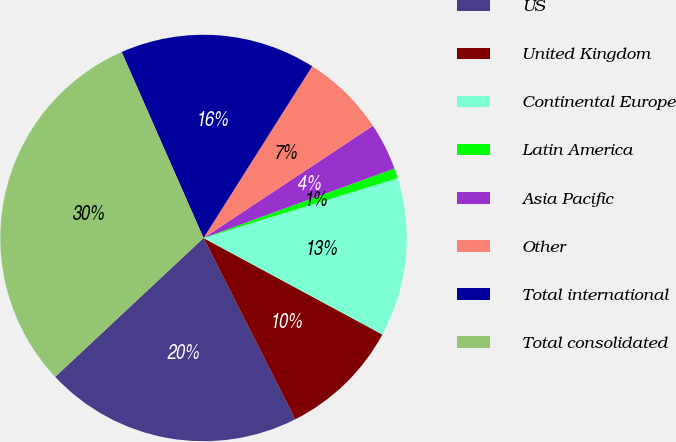Convert chart. <chart><loc_0><loc_0><loc_500><loc_500><pie_chart><fcel>US<fcel>United Kingdom<fcel>Continental Europe<fcel>Latin America<fcel>Asia Pacific<fcel>Other<fcel>Total international<fcel>Total consolidated<nl><fcel>20.48%<fcel>9.67%<fcel>12.63%<fcel>0.8%<fcel>3.75%<fcel>6.71%<fcel>15.58%<fcel>30.37%<nl></chart> 